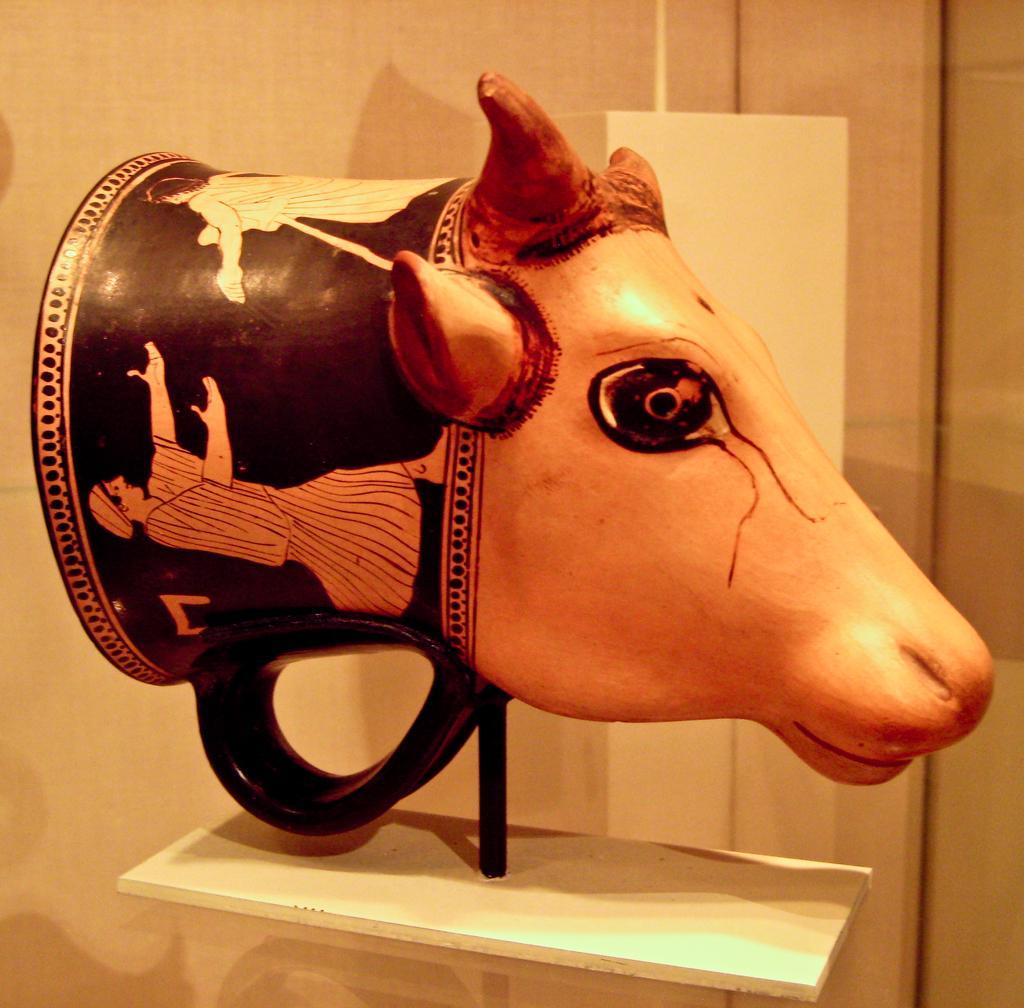Could you give a brief overview of what you see in this image? In this picture I can observe an inflatable bull head placed in the museum. In the background there is a wall. 